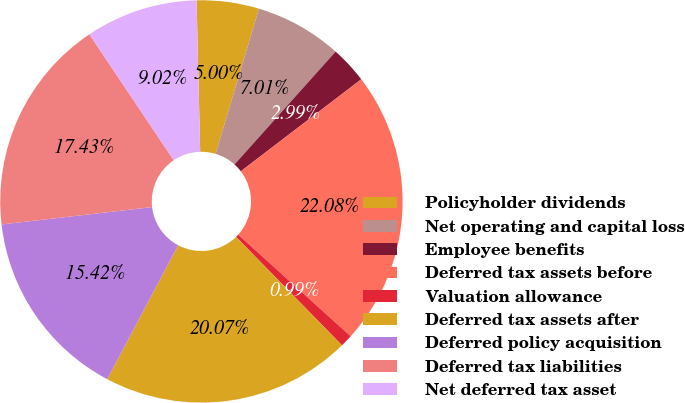<chart> <loc_0><loc_0><loc_500><loc_500><pie_chart><fcel>Policyholder dividends<fcel>Net operating and capital loss<fcel>Employee benefits<fcel>Deferred tax assets before<fcel>Valuation allowance<fcel>Deferred tax assets after<fcel>Deferred policy acquisition<fcel>Deferred tax liabilities<fcel>Net deferred tax asset<nl><fcel>5.0%<fcel>7.01%<fcel>2.99%<fcel>22.08%<fcel>0.99%<fcel>20.07%<fcel>15.42%<fcel>17.43%<fcel>9.02%<nl></chart> 